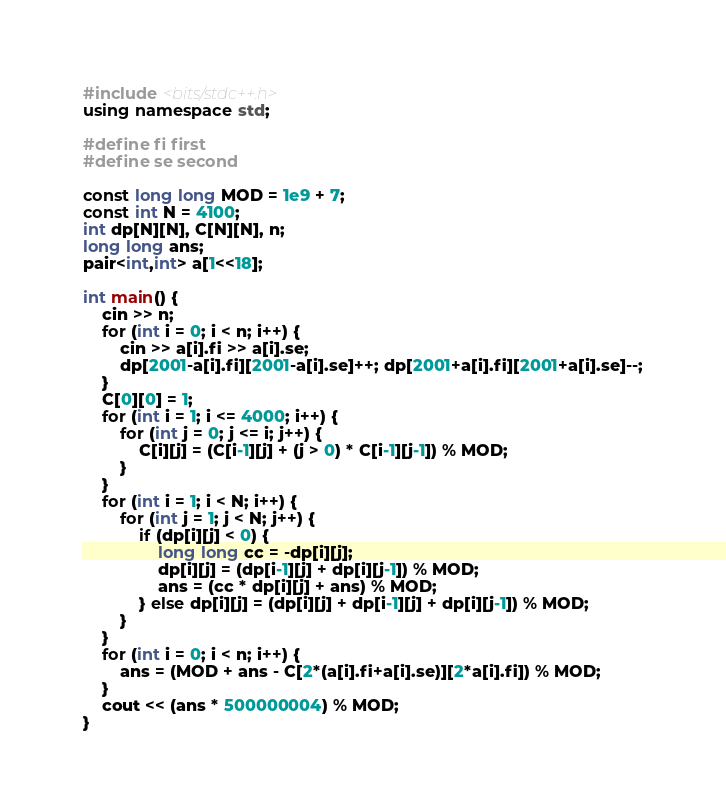Convert code to text. <code><loc_0><loc_0><loc_500><loc_500><_C++_>#include <bits/stdc++.h>
using namespace std;

#define fi first
#define se second

const long long MOD = 1e9 + 7;
const int N = 4100;
int dp[N][N], C[N][N], n;
long long ans;
pair<int,int> a[1<<18];

int main() {
    cin >> n;
    for (int i = 0; i < n; i++) {
        cin >> a[i].fi >> a[i].se;
        dp[2001-a[i].fi][2001-a[i].se]++; dp[2001+a[i].fi][2001+a[i].se]--;
    }
    C[0][0] = 1;
    for (int i = 1; i <= 4000; i++) {
        for (int j = 0; j <= i; j++) {
            C[i][j] = (C[i-1][j] + (j > 0) * C[i-1][j-1]) % MOD;
        }
    }
    for (int i = 1; i < N; i++) {
        for (int j = 1; j < N; j++) {
            if (dp[i][j] < 0) {
                long long cc = -dp[i][j];
                dp[i][j] = (dp[i-1][j] + dp[i][j-1]) % MOD;
                ans = (cc * dp[i][j] + ans) % MOD;
            } else dp[i][j] = (dp[i][j] + dp[i-1][j] + dp[i][j-1]) % MOD;
        }
    }
    for (int i = 0; i < n; i++) {
        ans = (MOD + ans - C[2*(a[i].fi+a[i].se)][2*a[i].fi]) % MOD;
    }
    cout << (ans * 500000004) % MOD;
}
</code> 